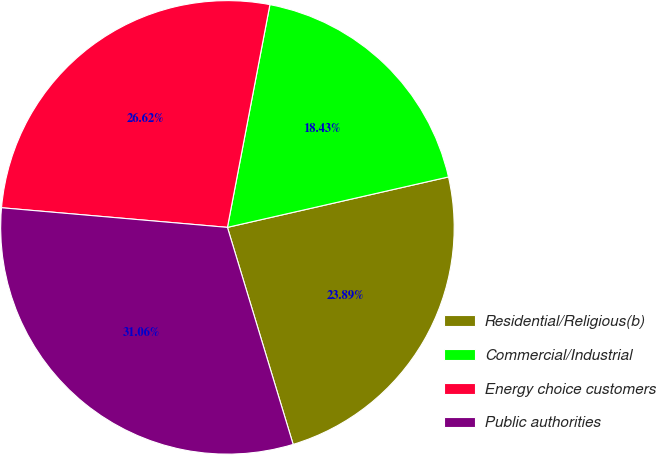Convert chart to OTSL. <chart><loc_0><loc_0><loc_500><loc_500><pie_chart><fcel>Residential/Religious(b)<fcel>Commercial/Industrial<fcel>Energy choice customers<fcel>Public authorities<nl><fcel>23.89%<fcel>18.43%<fcel>26.62%<fcel>31.06%<nl></chart> 